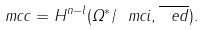<formula> <loc_0><loc_0><loc_500><loc_500>\ m c c = H ^ { n - l } ( \Omega ^ { * } / \ m c i , \overline { \ e d } ) .</formula> 